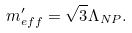Convert formula to latex. <formula><loc_0><loc_0><loc_500><loc_500>m ^ { \prime } _ { e f f } = \sqrt { 3 } \Lambda _ { N P } .</formula> 